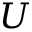Convert formula to latex. <formula><loc_0><loc_0><loc_500><loc_500>U</formula> 